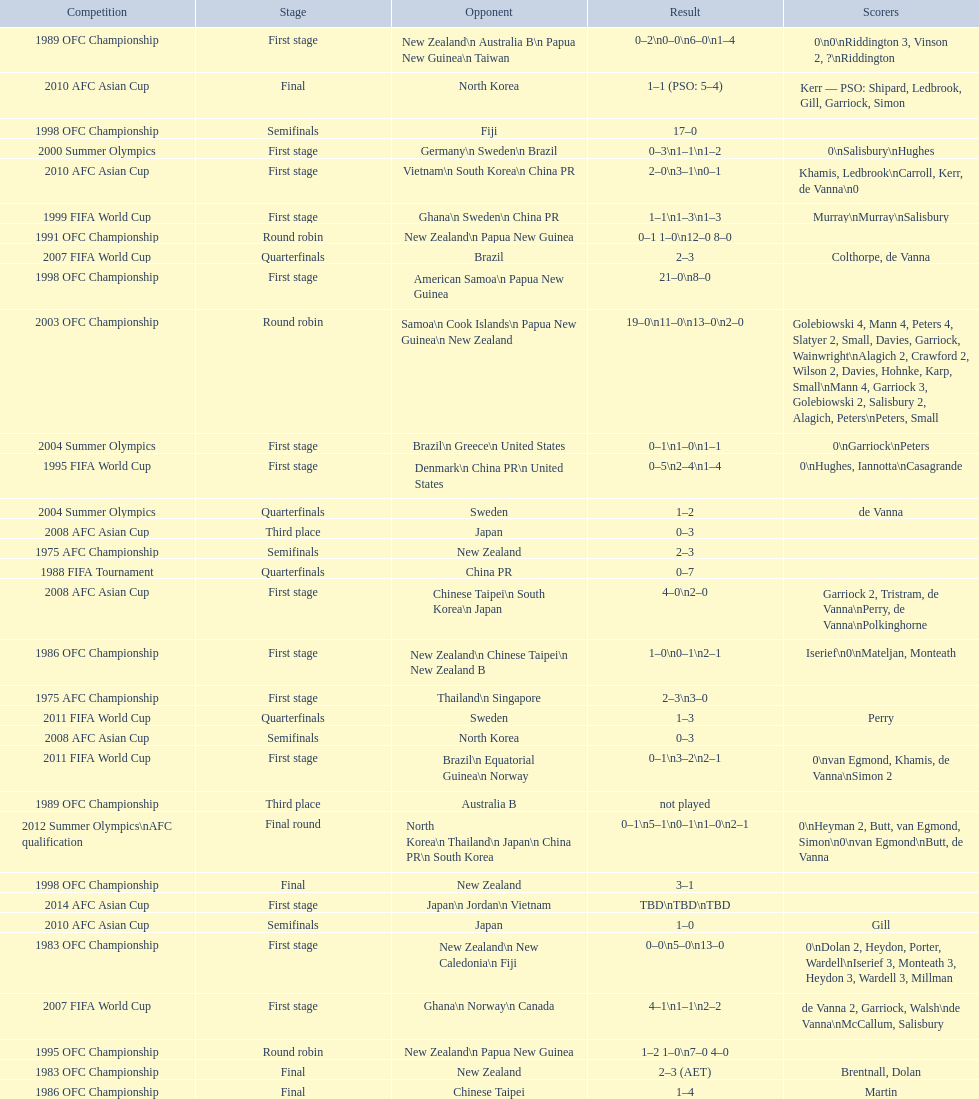What was the overall number of goals scored during the 1983 ofc championship? 18. 